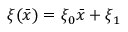<formula> <loc_0><loc_0><loc_500><loc_500>\xi ( \bar { x } ) = \xi _ { 0 } \bar { x } + \xi _ { 1 }</formula> 